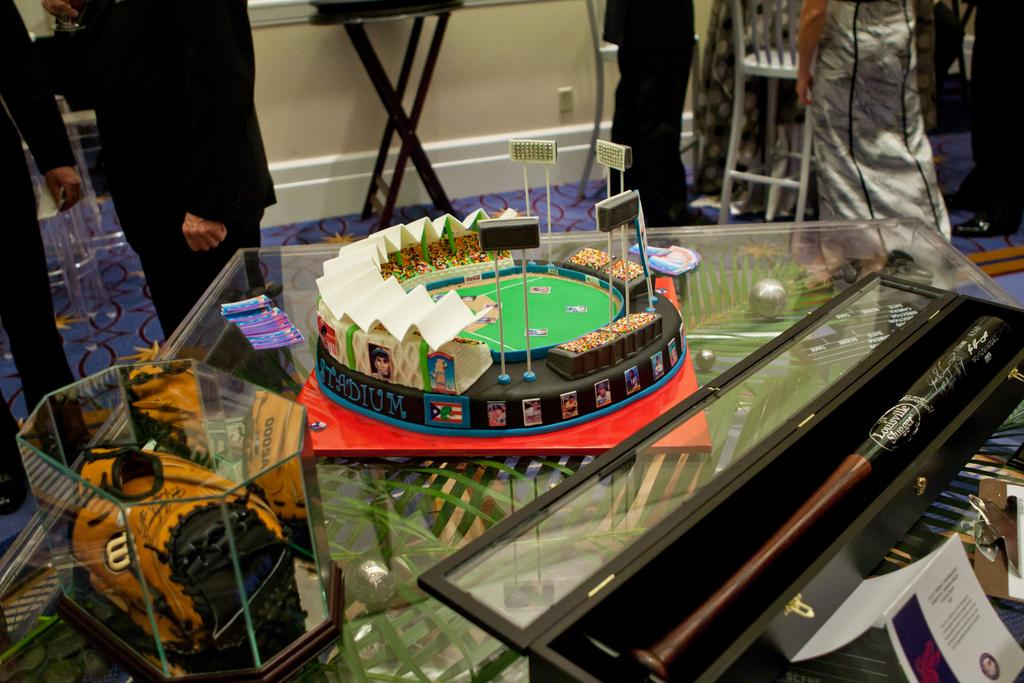What type of table is visible in the image? There is a glass table in the image. What can be seen on the glass table? There are objects on the glass table. Can you describe the people in the background of the image? There are persons standing in the background of the image. What type of baseball shirt is the person wearing in the image? There is no baseball shirt or any reference to baseball in the image. 